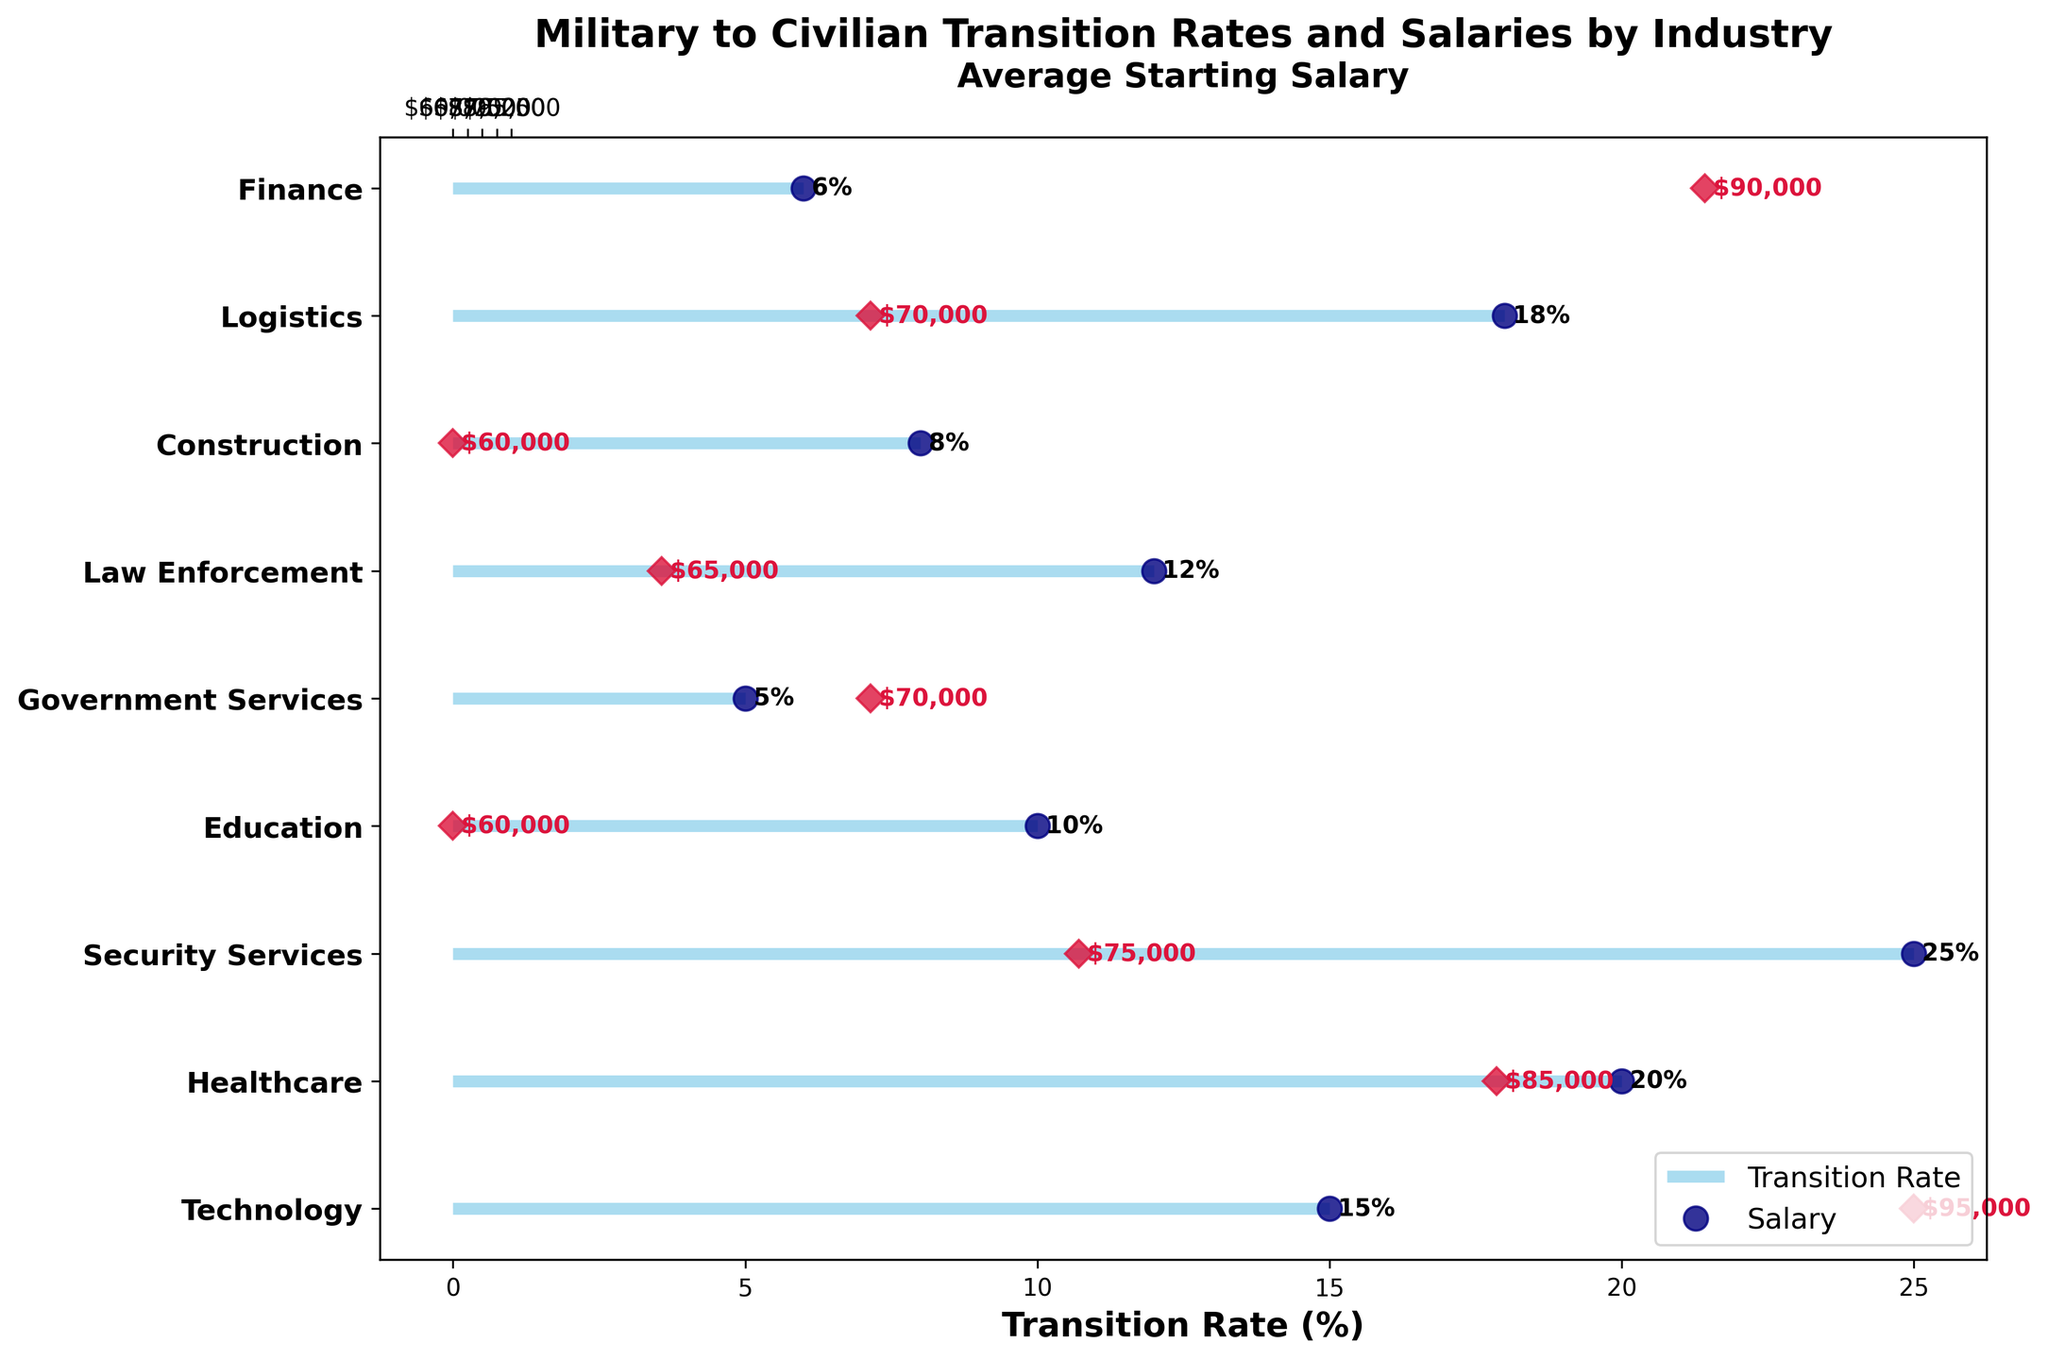What is the transition rate for the Technology industry? The Technology industry's transition rate is depicted by the length of the line on the horizontal axis.
Answer: 15% Which industry has the lowest transition rate? By observing the shortest line, we see that Government Services has the lowest transition rate.
Answer: Government Services Which industry offers the highest average starting salary? The highest normalized salary marker (crimson diamond) corresponds to the data point plotted furthest to the right on the secondary axis.
Answer: Technology How do the transition rates of Security Services and Law Enforcement compare? By comparing the lengths of the lines, we see that Security Services has a longer line, indicating a higher transition rate than Law Enforcement.
Answer: Security Services has a higher transition rate What is the difference in average starting salary between Finance and Education? The average starting salaries on the secondary axis show that Finance has $90,000 and Education has $60,000. Thus, the difference is $90,000 - $60,000.
Answer: $30,000 Which industry has the highest transition rate? The longest line on the primary horizontal axis for transition rates is for Security Services.
Answer: Security Services How many industries have a transition rate higher than 10%? By counting the lines that extend beyond the 10% mark on the primary axis, we find the industries Technology, Healthcare, Security Services, Law Enforcement, and Logistics.
Answer: 5 industries What is the normalized value of the average starting salary for Logistics if the range is from $60,000 to $95,000? The normalized value can be found by calculating (70000 - 60000) / (95000 - 60000).
Answer: 0.286 Which industry has the lowest average starting salary and what is it? The lowest marker on the secondary axis indicates that Education has the lowest starting salary.
Answer: Education, $60,000 